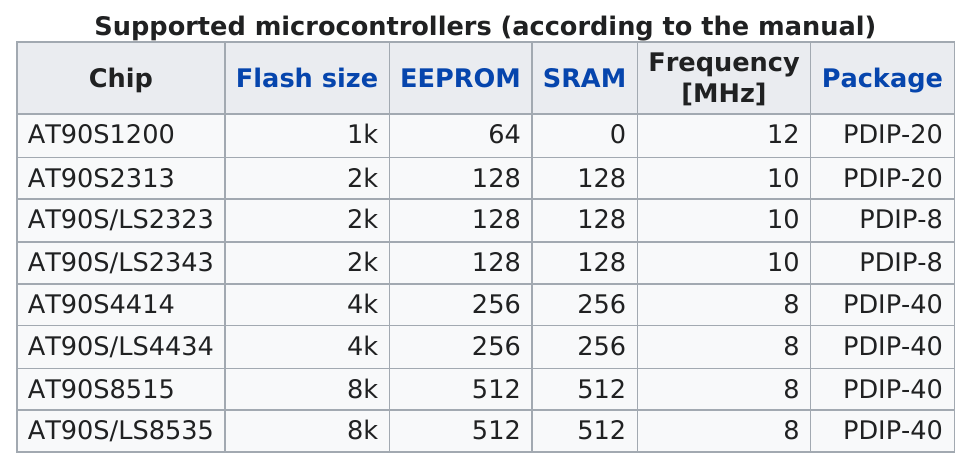Give some essential details in this illustration. The AT90S8515 chip has a larger flash size than the AT90S/LS4434 chip. There are at least 3,000 chips that have a flash size. The AT90S1200 chip has the highest frequency among the chips available. The AT90S4414 microcontroller was the first to feature a flash size of 4K bytes. The flash size of the AT90S/LS4434 microcontroller is the same as that of the AT90S4414 microcontroller. 